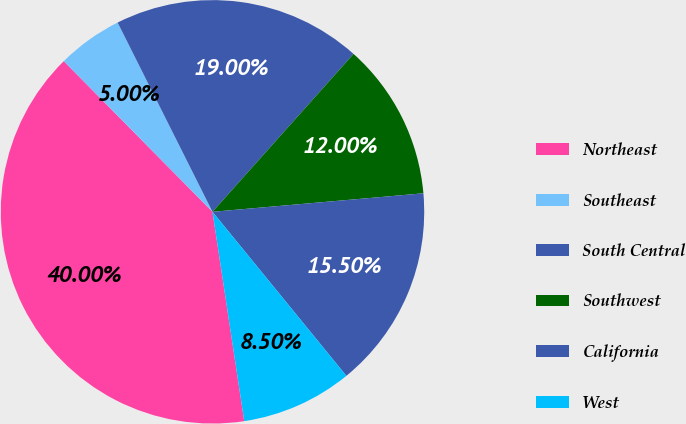<chart> <loc_0><loc_0><loc_500><loc_500><pie_chart><fcel>Northeast<fcel>Southeast<fcel>South Central<fcel>Southwest<fcel>California<fcel>West<nl><fcel>40.0%<fcel>5.0%<fcel>19.0%<fcel>12.0%<fcel>15.5%<fcel>8.5%<nl></chart> 